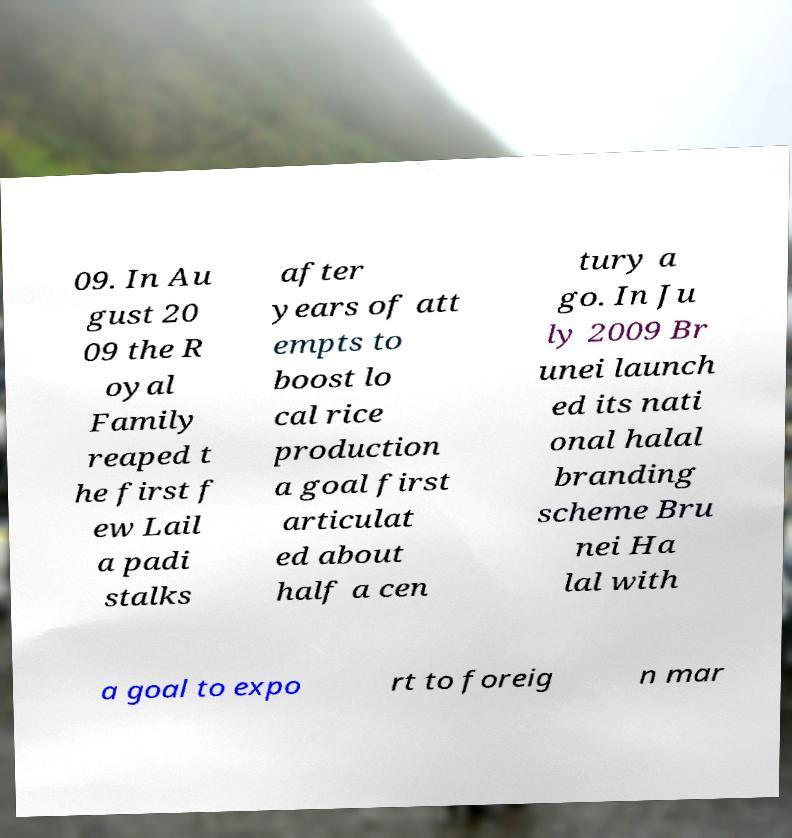There's text embedded in this image that I need extracted. Can you transcribe it verbatim? 09. In Au gust 20 09 the R oyal Family reaped t he first f ew Lail a padi stalks after years of att empts to boost lo cal rice production a goal first articulat ed about half a cen tury a go. In Ju ly 2009 Br unei launch ed its nati onal halal branding scheme Bru nei Ha lal with a goal to expo rt to foreig n mar 